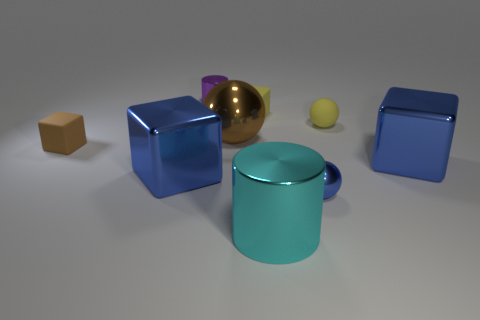Add 1 brown spheres. How many objects exist? 10 Subtract all purple blocks. Subtract all yellow spheres. How many blocks are left? 4 Subtract all spheres. How many objects are left? 6 Add 5 tiny red metallic blocks. How many tiny red metallic blocks exist? 5 Subtract 1 yellow balls. How many objects are left? 8 Subtract all metal spheres. Subtract all small yellow balls. How many objects are left? 6 Add 4 purple objects. How many purple objects are left? 5 